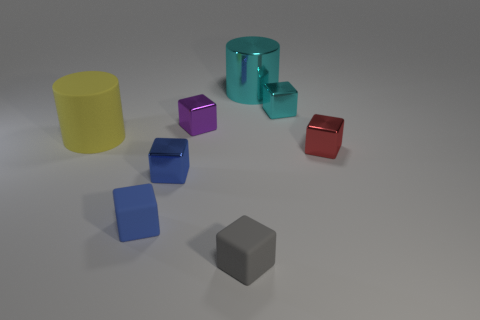Subtract all tiny blue rubber blocks. How many blocks are left? 5 Subtract all purple blocks. How many blocks are left? 5 Subtract 2 cubes. How many cubes are left? 4 Subtract all gray blocks. Subtract all red cylinders. How many blocks are left? 5 Add 1 tiny red matte balls. How many objects exist? 9 Subtract all cubes. How many objects are left? 2 Add 2 small cyan cubes. How many small cyan cubes are left? 3 Add 6 small blue shiny blocks. How many small blue shiny blocks exist? 7 Subtract 0 purple balls. How many objects are left? 8 Subtract all purple metallic things. Subtract all blue blocks. How many objects are left? 5 